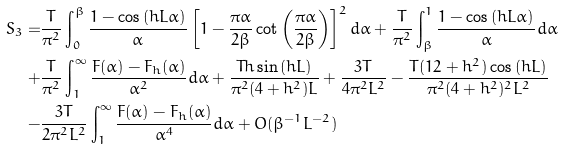Convert formula to latex. <formula><loc_0><loc_0><loc_500><loc_500>S _ { 3 } = & \frac { T } { \pi ^ { 2 } } \int _ { 0 } ^ { \beta } \frac { 1 - \cos { ( h L \alpha ) } } { \alpha } \left [ 1 - \frac { \pi \alpha } { 2 \beta } \cot { \left ( \frac { \pi \alpha } { 2 \beta } \right ) } \right ] ^ { 2 } d \alpha + \frac { T } { \pi ^ { 2 } } \int _ { \beta } ^ { 1 } \frac { 1 - \cos { ( h L \alpha ) } } { \alpha } d \alpha \\ + & \frac { T } { \pi ^ { 2 } } \int _ { 1 } ^ { \infty } \frac { F ( \alpha ) - F _ { h } ( \alpha ) } { \alpha ^ { 2 } } d \alpha + \frac { T h \sin { ( h L ) } } { \pi ^ { 2 } ( 4 + h ^ { 2 } ) L } + \frac { 3 T } { 4 \pi ^ { 2 } L ^ { 2 } } - \frac { T ( 1 2 + h ^ { 2 } ) \cos { ( h L ) } } { \pi ^ { 2 } ( 4 + h ^ { 2 } ) ^ { 2 } L ^ { 2 } } \\ - & \frac { 3 T } { 2 \pi ^ { 2 } L ^ { 2 } } \int _ { 1 } ^ { \infty } \frac { F ( \alpha ) - F _ { h } ( \alpha ) } { \alpha ^ { 4 } } d \alpha + O ( \beta ^ { - 1 } L ^ { - 2 } )</formula> 